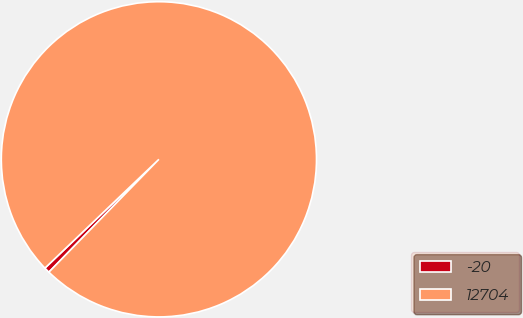<chart> <loc_0><loc_0><loc_500><loc_500><pie_chart><fcel>-20<fcel>12704<nl><fcel>0.57%<fcel>99.43%<nl></chart> 